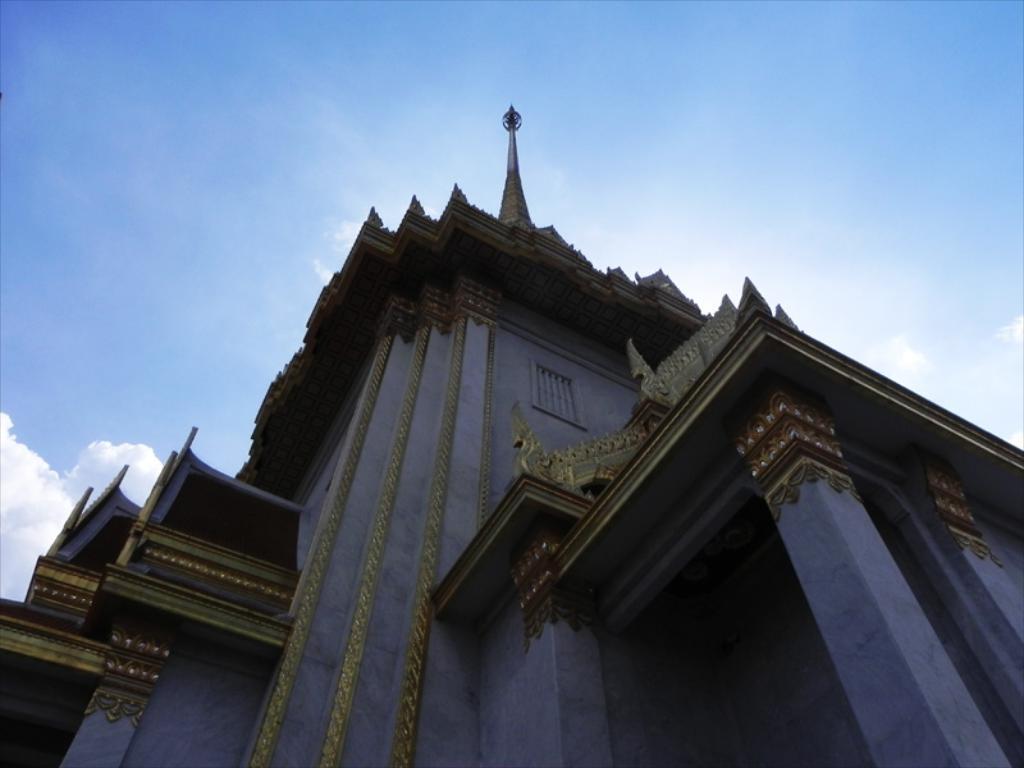Please provide a concise description of this image. In this image in the center there is a building and there are some pillars, at the top there is sky and on the building there is some tower. 